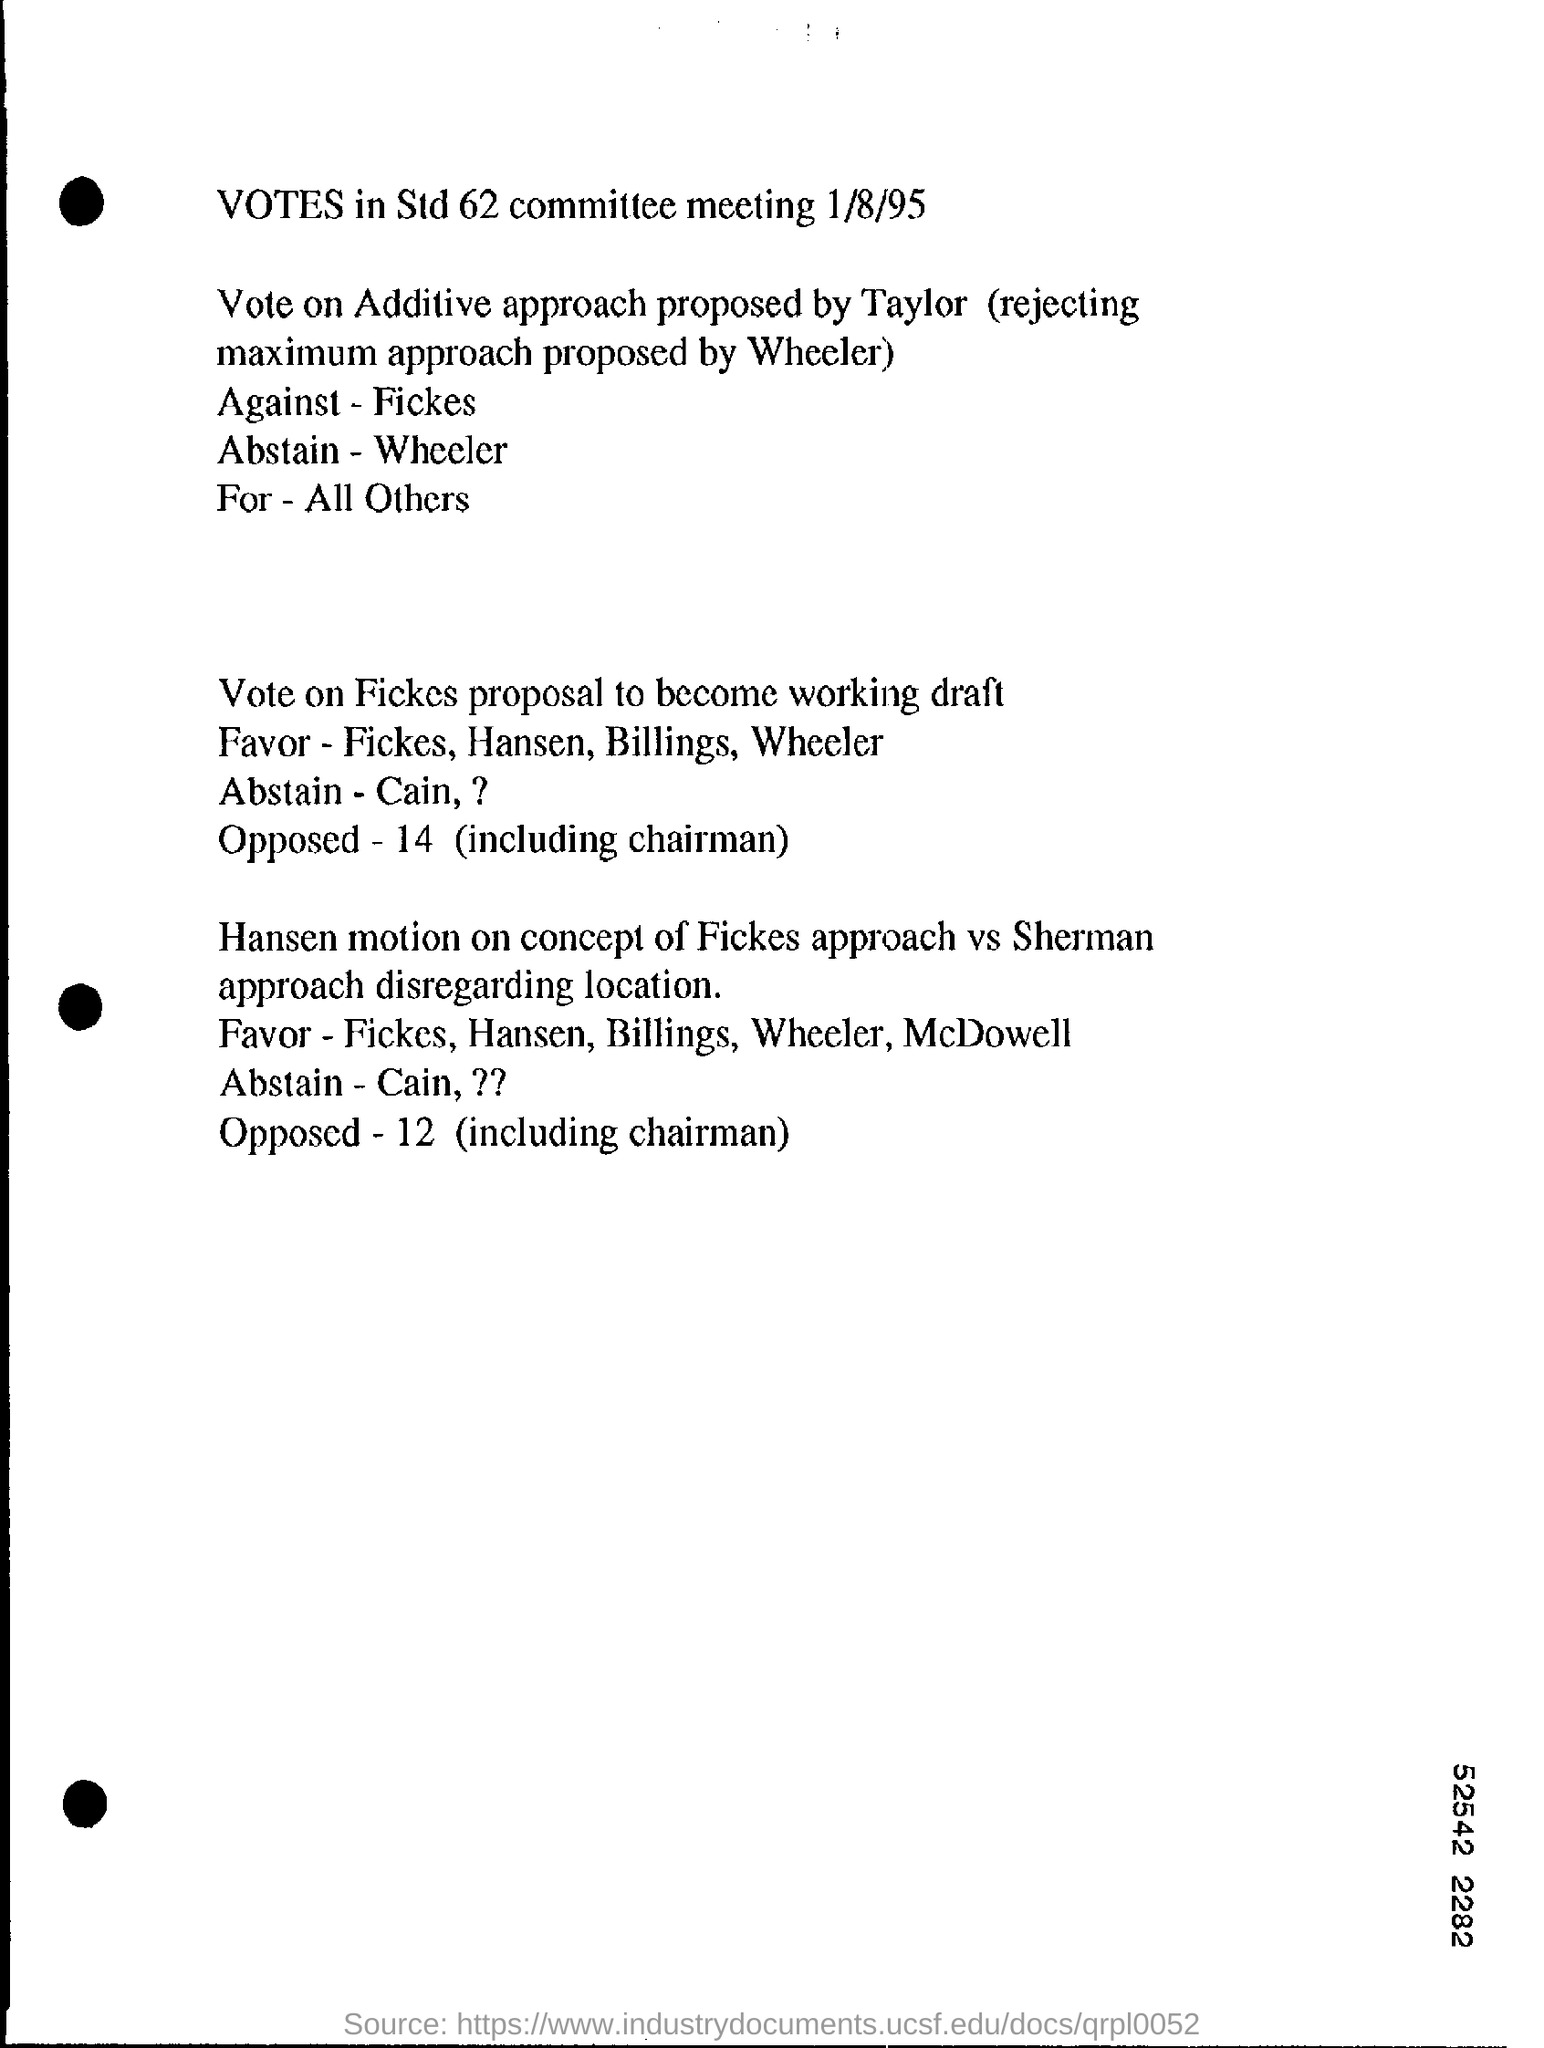How many number of votes are opposed on fickes proposal to become working draft ?
Offer a terse response. 14. Who is voting against vote on additive approach proposed by taylor ?
Give a very brief answer. Fickes. 